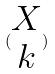<formula> <loc_0><loc_0><loc_500><loc_500>( \begin{matrix} X \\ k \end{matrix} )</formula> 